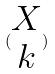<formula> <loc_0><loc_0><loc_500><loc_500>( \begin{matrix} X \\ k \end{matrix} )</formula> 